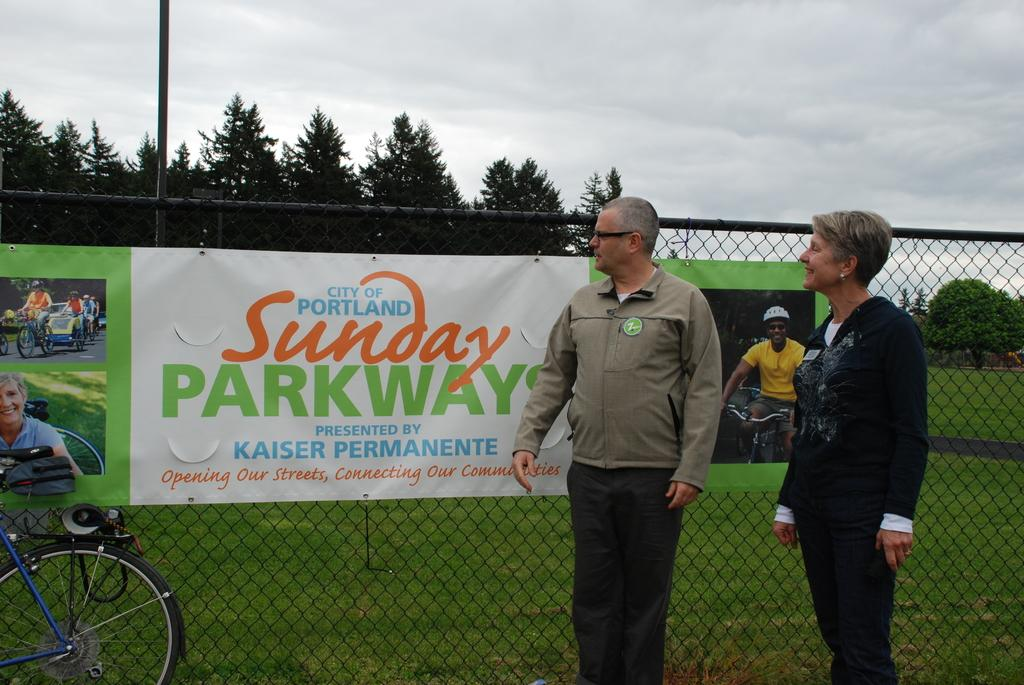How many people are present in the image? There is a man and a woman in the image, making a total of two people. What are the man and woman standing in front of? They are standing in front of a banner. What else can be seen in the image besides the man, woman, and banner? There is a vehicle, a fence, and the sky and trees in the background. What type of list can be seen in the image? There is no list present in the image. What school are the man and woman attending in the image? There is no indication that the man and woman are attending a school in the image. 